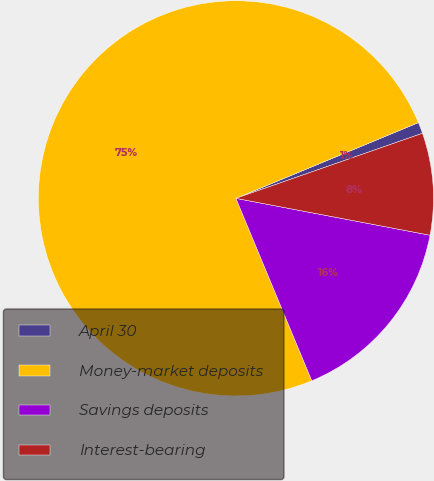<chart> <loc_0><loc_0><loc_500><loc_500><pie_chart><fcel>April 30<fcel>Money-market deposits<fcel>Savings deposits<fcel>Interest-bearing<nl><fcel>0.92%<fcel>75.02%<fcel>15.74%<fcel>8.33%<nl></chart> 